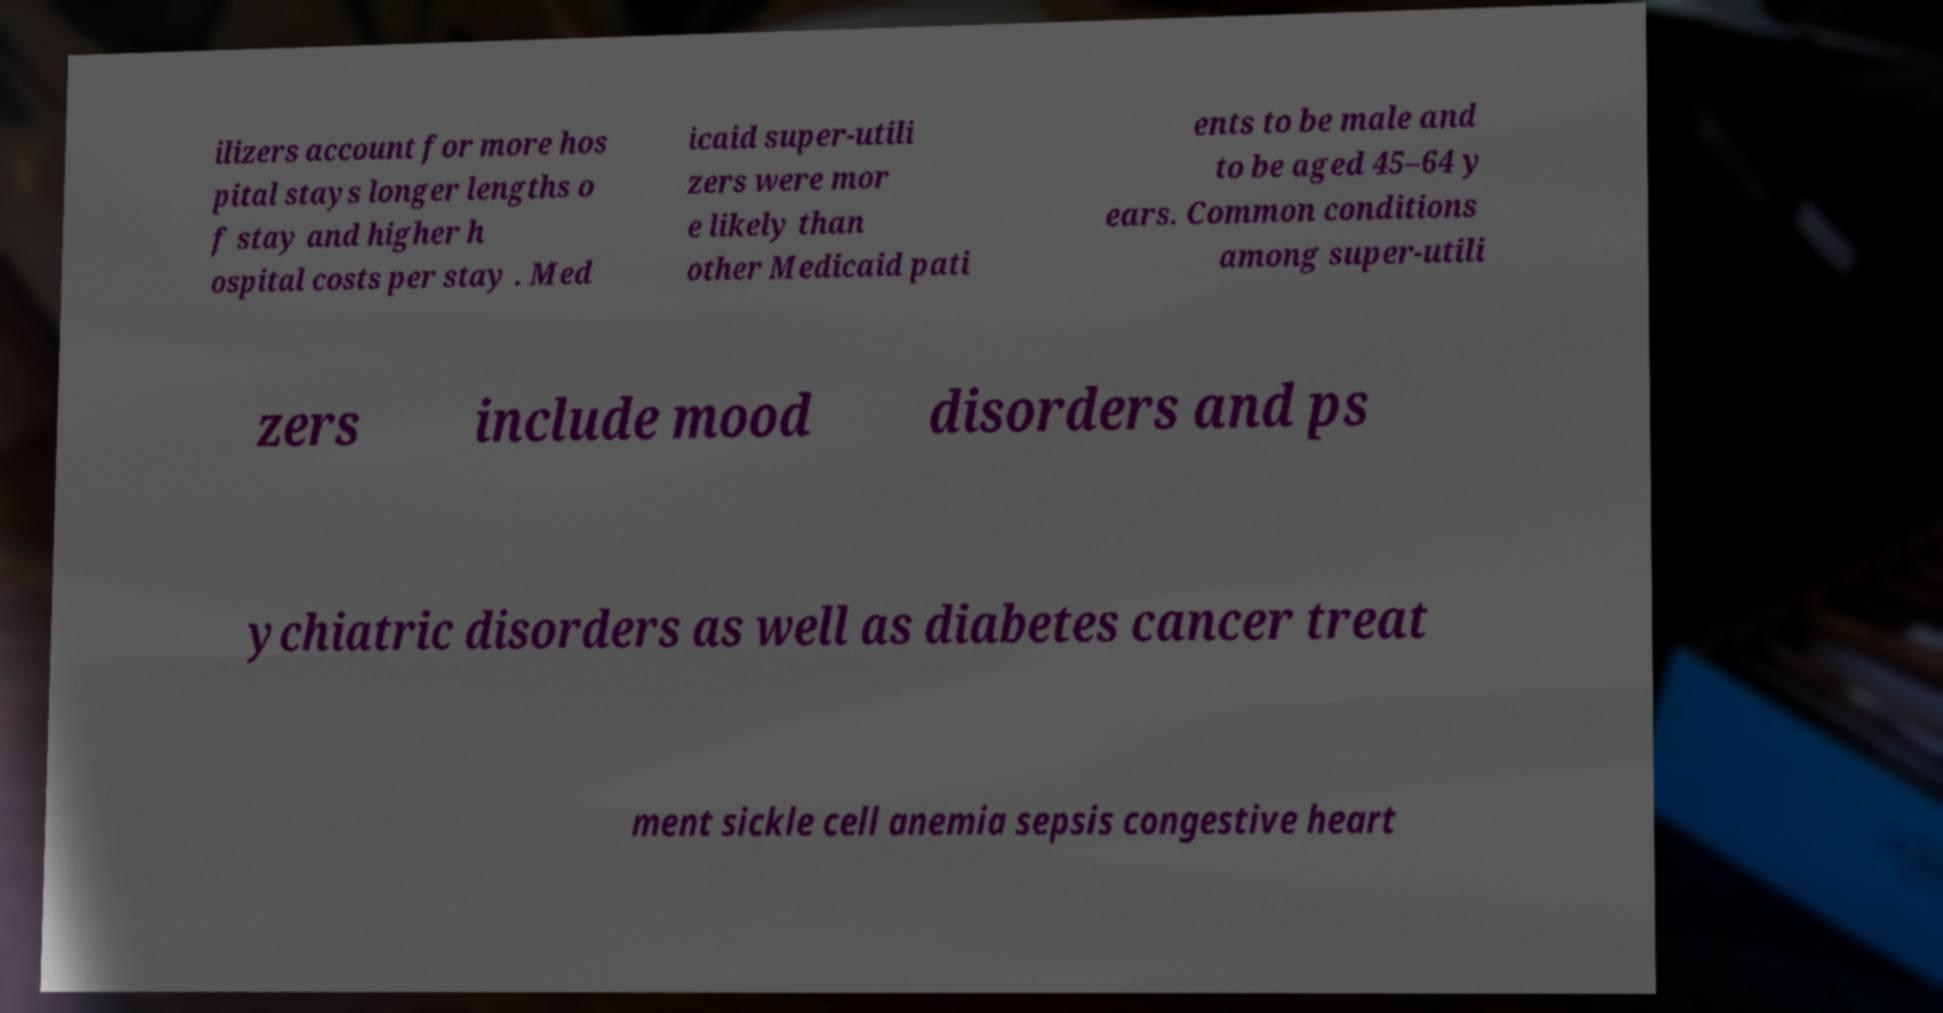Could you extract and type out the text from this image? ilizers account for more hos pital stays longer lengths o f stay and higher h ospital costs per stay . Med icaid super-utili zers were mor e likely than other Medicaid pati ents to be male and to be aged 45–64 y ears. Common conditions among super-utili zers include mood disorders and ps ychiatric disorders as well as diabetes cancer treat ment sickle cell anemia sepsis congestive heart 